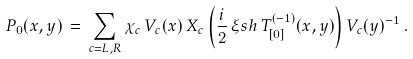Convert formula to latex. <formula><loc_0><loc_0><loc_500><loc_500>P _ { 0 } ( x , y ) \, = \, \sum _ { c = L , R } \chi _ { c } \, V _ { c } ( x ) \, X _ { c } \left ( \frac { i } { 2 } \, \xi \sl s h \, T ^ { ( - 1 ) } _ { [ 0 ] } ( x , y ) \right ) V _ { c } ( y ) ^ { - 1 } \, .</formula> 